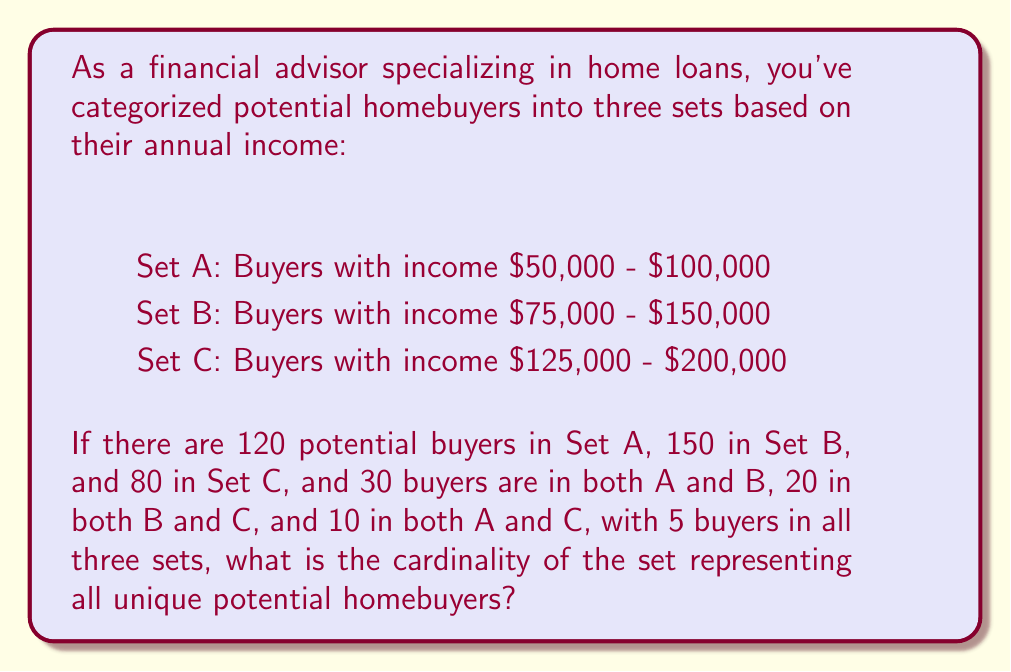What is the answer to this math problem? To solve this problem, we need to use the principle of inclusion-exclusion for three sets. Let's break it down step-by-step:

1. First, let's define our universe U as the set of all unique potential homebuyers.

2. We're given:
   $|A| = 120$, $|B| = 150$, $|C| = 80$
   $|A \cap B| = 30$, $|B \cap C| = 20$, $|A \cap C| = 10$
   $|A \cap B \cap C| = 5$

3. The formula for the cardinality of the union of three sets is:

   $$|A \cup B \cup C| = |A| + |B| + |C| - |A \cap B| - |B \cap C| - |A \cap C| + |A \cap B \cap C|$$

4. Let's substitute our values:

   $$|U| = 120 + 150 + 80 - 30 - 20 - 10 + 5$$

5. Now we can calculate:

   $$|U| = 350 - 60 + 5 = 295$$

Therefore, the cardinality of the set representing all unique potential homebuyers is 295.
Answer: 295 